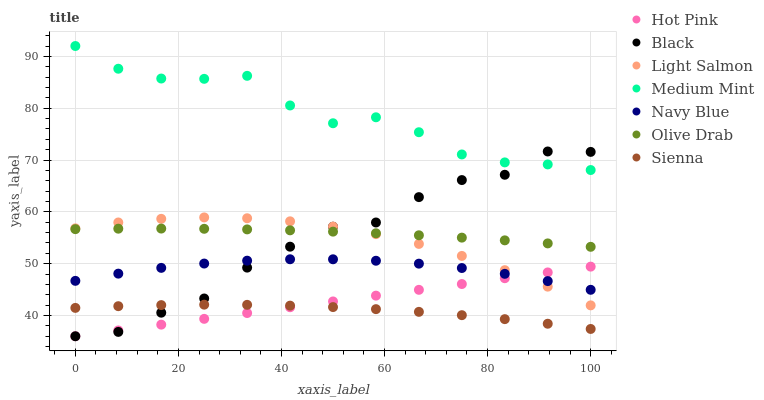Does Sienna have the minimum area under the curve?
Answer yes or no. Yes. Does Medium Mint have the maximum area under the curve?
Answer yes or no. Yes. Does Light Salmon have the minimum area under the curve?
Answer yes or no. No. Does Light Salmon have the maximum area under the curve?
Answer yes or no. No. Is Hot Pink the smoothest?
Answer yes or no. Yes. Is Black the roughest?
Answer yes or no. Yes. Is Light Salmon the smoothest?
Answer yes or no. No. Is Light Salmon the roughest?
Answer yes or no. No. Does Hot Pink have the lowest value?
Answer yes or no. Yes. Does Light Salmon have the lowest value?
Answer yes or no. No. Does Medium Mint have the highest value?
Answer yes or no. Yes. Does Light Salmon have the highest value?
Answer yes or no. No. Is Sienna less than Medium Mint?
Answer yes or no. Yes. Is Medium Mint greater than Light Salmon?
Answer yes or no. Yes. Does Light Salmon intersect Black?
Answer yes or no. Yes. Is Light Salmon less than Black?
Answer yes or no. No. Is Light Salmon greater than Black?
Answer yes or no. No. Does Sienna intersect Medium Mint?
Answer yes or no. No. 